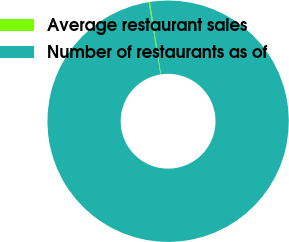<chart> <loc_0><loc_0><loc_500><loc_500><pie_chart><fcel>Average restaurant sales<fcel>Number of restaurants as of<nl><fcel>0.17%<fcel>99.83%<nl></chart> 